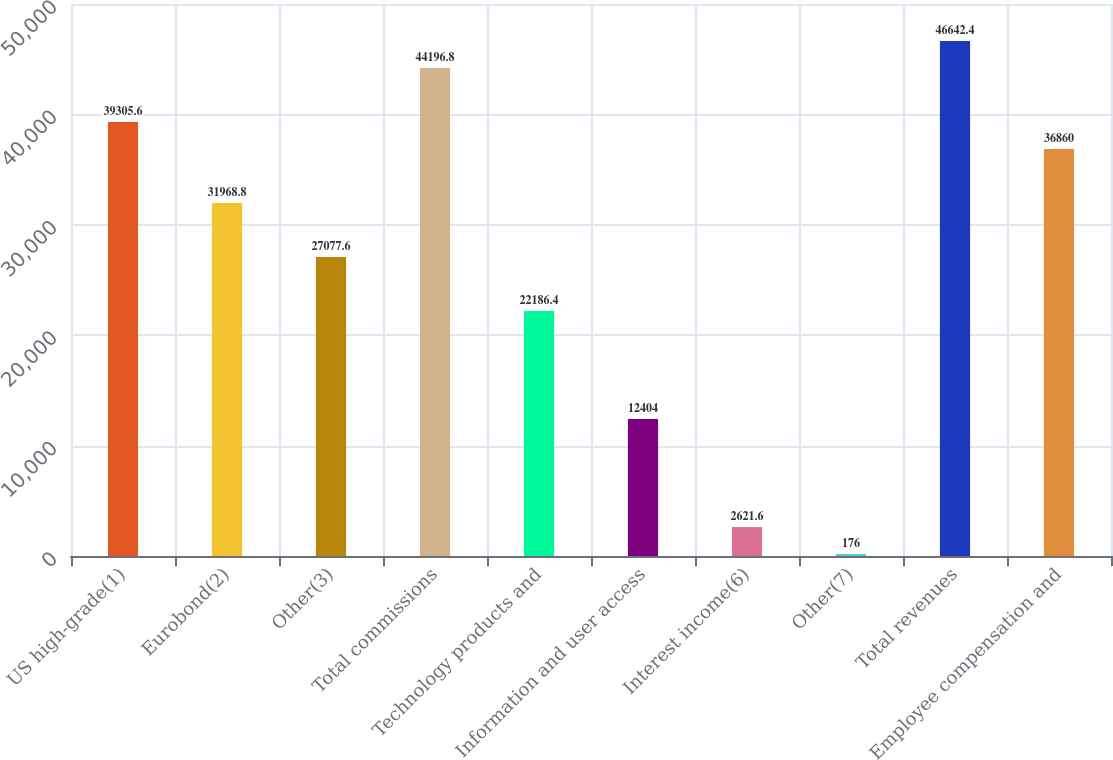Convert chart. <chart><loc_0><loc_0><loc_500><loc_500><bar_chart><fcel>US high-grade(1)<fcel>Eurobond(2)<fcel>Other(3)<fcel>Total commissions<fcel>Technology products and<fcel>Information and user access<fcel>Interest income(6)<fcel>Other(7)<fcel>Total revenues<fcel>Employee compensation and<nl><fcel>39305.6<fcel>31968.8<fcel>27077.6<fcel>44196.8<fcel>22186.4<fcel>12404<fcel>2621.6<fcel>176<fcel>46642.4<fcel>36860<nl></chart> 